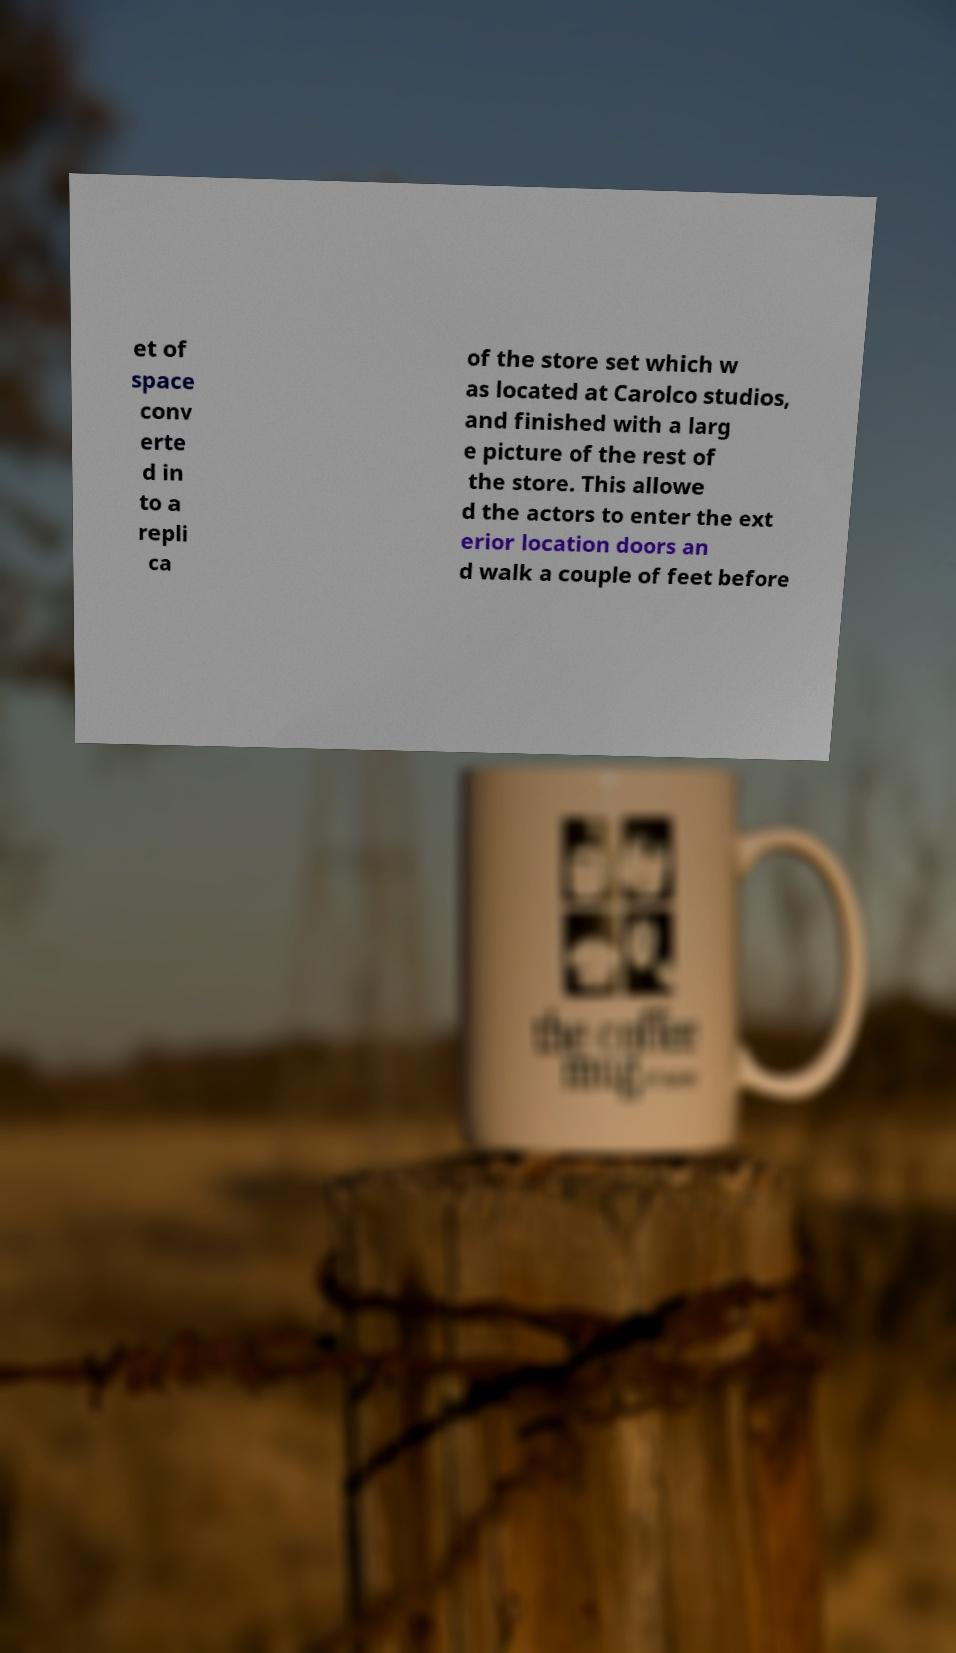Please read and relay the text visible in this image. What does it say? et of space conv erte d in to a repli ca of the store set which w as located at Carolco studios, and finished with a larg e picture of the rest of the store. This allowe d the actors to enter the ext erior location doors an d walk a couple of feet before 